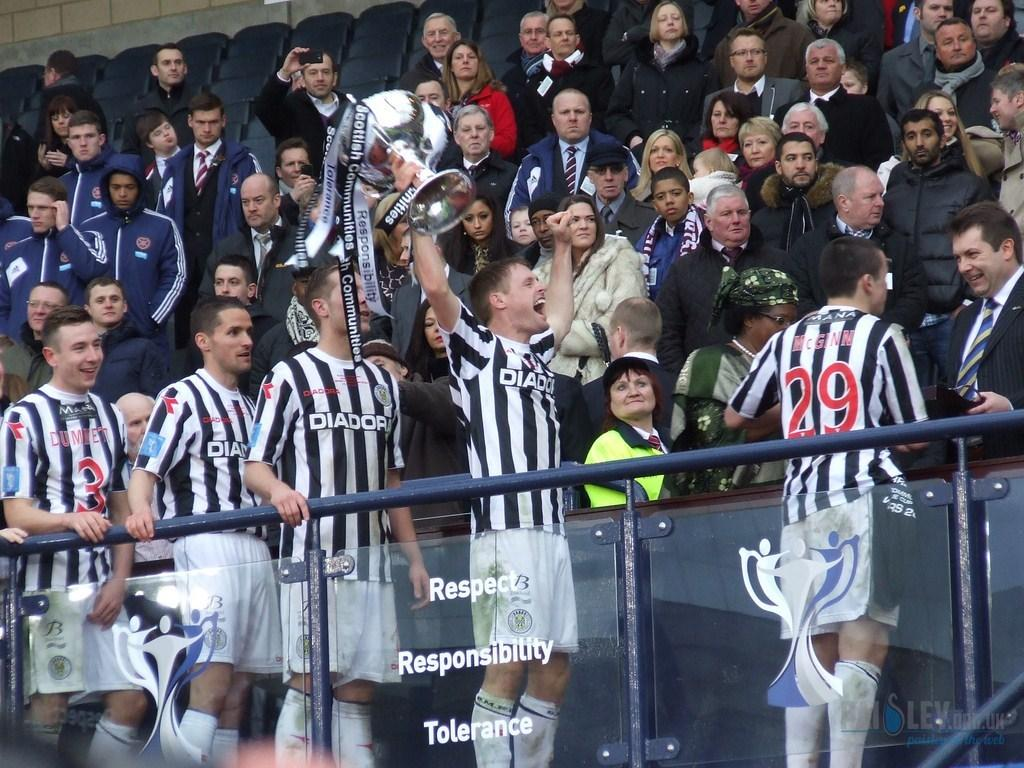<image>
Provide a brief description of the given image. The clear, plexiglass in front of the men in black and white shirts with white shorts has writing in white that says Respect  Responsibility Tolerance. 